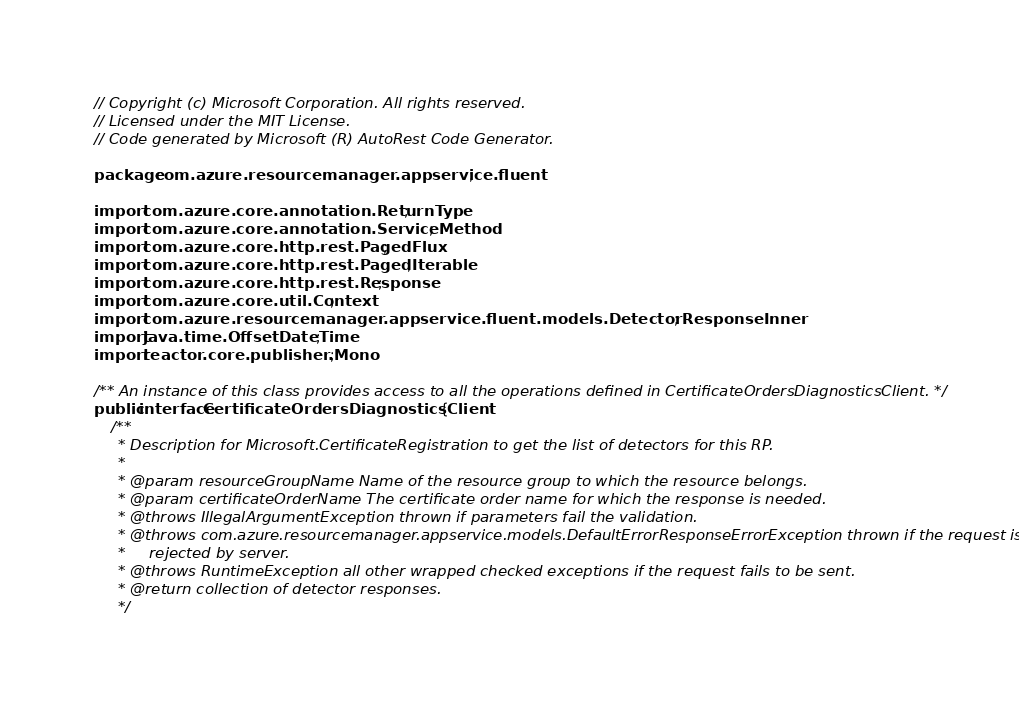Convert code to text. <code><loc_0><loc_0><loc_500><loc_500><_Java_>// Copyright (c) Microsoft Corporation. All rights reserved.
// Licensed under the MIT License.
// Code generated by Microsoft (R) AutoRest Code Generator.

package com.azure.resourcemanager.appservice.fluent;

import com.azure.core.annotation.ReturnType;
import com.azure.core.annotation.ServiceMethod;
import com.azure.core.http.rest.PagedFlux;
import com.azure.core.http.rest.PagedIterable;
import com.azure.core.http.rest.Response;
import com.azure.core.util.Context;
import com.azure.resourcemanager.appservice.fluent.models.DetectorResponseInner;
import java.time.OffsetDateTime;
import reactor.core.publisher.Mono;

/** An instance of this class provides access to all the operations defined in CertificateOrdersDiagnosticsClient. */
public interface CertificateOrdersDiagnosticsClient {
    /**
     * Description for Microsoft.CertificateRegistration to get the list of detectors for this RP.
     *
     * @param resourceGroupName Name of the resource group to which the resource belongs.
     * @param certificateOrderName The certificate order name for which the response is needed.
     * @throws IllegalArgumentException thrown if parameters fail the validation.
     * @throws com.azure.resourcemanager.appservice.models.DefaultErrorResponseErrorException thrown if the request is
     *     rejected by server.
     * @throws RuntimeException all other wrapped checked exceptions if the request fails to be sent.
     * @return collection of detector responses.
     */</code> 